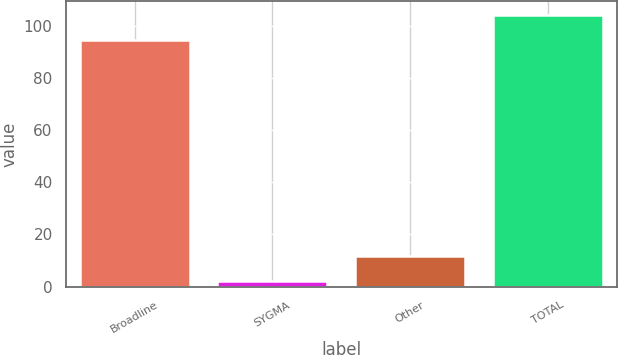Convert chart. <chart><loc_0><loc_0><loc_500><loc_500><bar_chart><fcel>Broadline<fcel>SYGMA<fcel>Other<fcel>TOTAL<nl><fcel>94.5<fcel>2<fcel>11.8<fcel>104.3<nl></chart> 